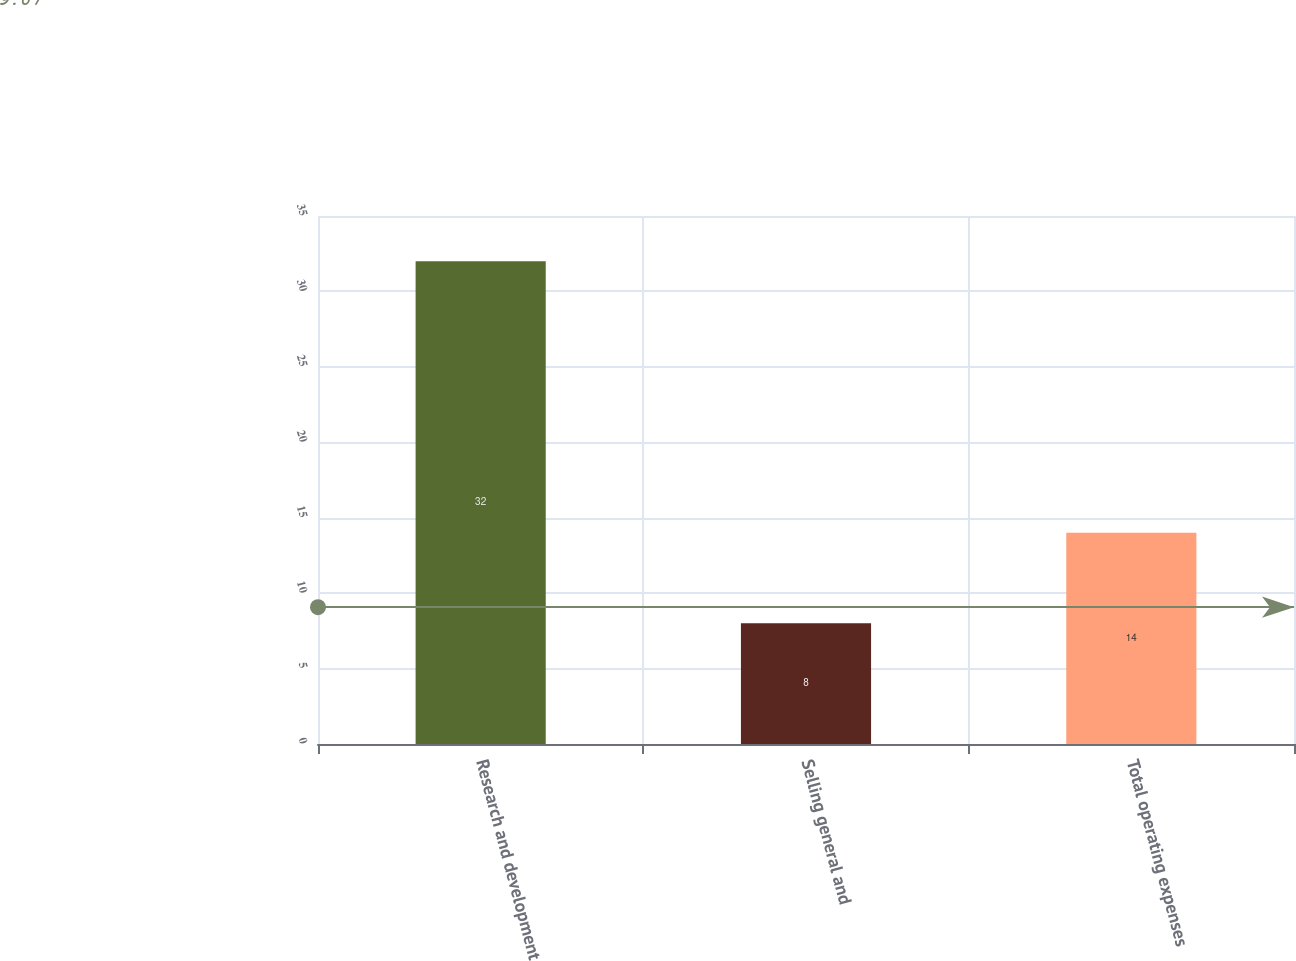Convert chart to OTSL. <chart><loc_0><loc_0><loc_500><loc_500><bar_chart><fcel>Research and development<fcel>Selling general and<fcel>Total operating expenses<nl><fcel>32<fcel>8<fcel>14<nl></chart> 